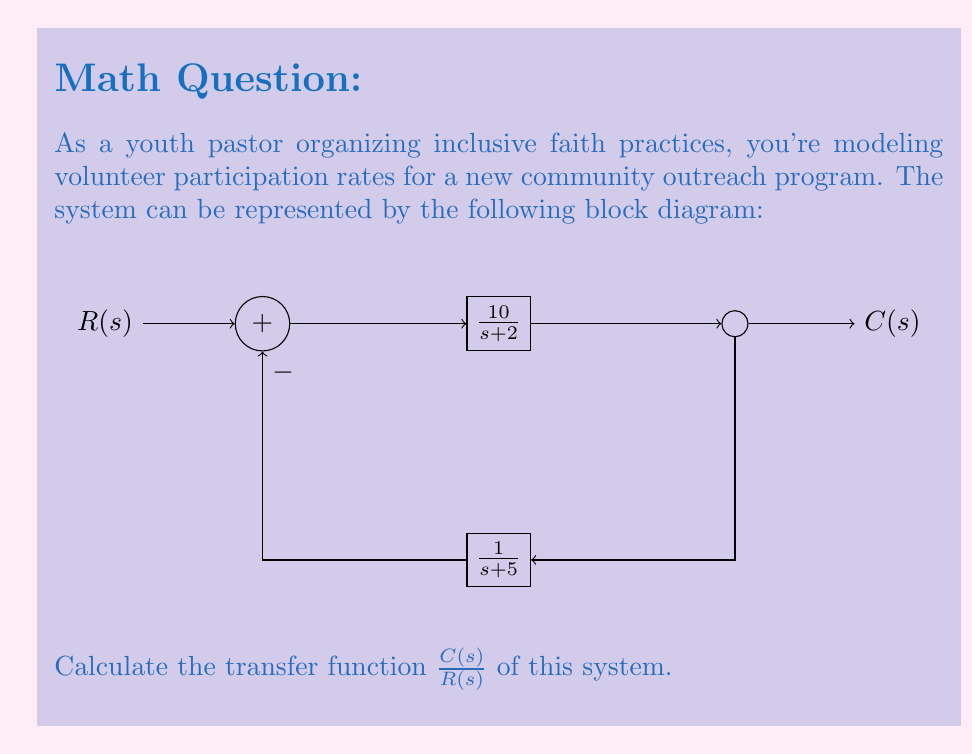Help me with this question. Let's approach this step-by-step:

1) First, we identify the forward path gain and the feedback path gain:
   Forward path gain: $G(s) = \frac{10}{s+2}$
   Feedback path gain: $H(s) = \frac{1}{s+5}$

2) The general form of a closed-loop transfer function is:
   $$\frac{C(s)}{R(s)} = \frac{G(s)}{1 + G(s)H(s)}$$

3) Let's substitute our $G(s)$ and $H(s)$:
   $$\frac{C(s)}{R(s)} = \frac{\frac{10}{s+2}}{1 + \frac{10}{s+2} \cdot \frac{1}{s+5}}$$

4) Multiply numerator and denominator by $(s+2)(s+5)$ to eliminate fractions:
   $$\frac{C(s)}{R(s)} = \frac{10(s+5)}{(s+2)(s+5) + 10}$$

5) Expand the denominator:
   $$\frac{C(s)}{R(s)} = \frac{10(s+5)}{s^2 + 7s + 10 + 10}$$

6) Simplify:
   $$\frac{C(s)}{R(s)} = \frac{10s + 50}{s^2 + 7s + 20}$$

This final form represents the transfer function of the system modeling volunteer participation rates for your inclusive faith practice program.
Answer: $$\frac{C(s)}{R(s)} = \frac{10s + 50}{s^2 + 7s + 20}$$ 